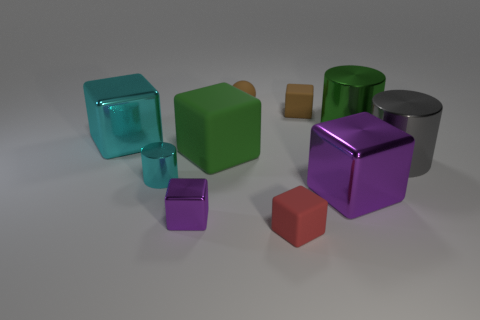There is a small rubber block that is behind the large green cylinder; is its color the same as the sphere that is to the left of the large green cylinder?
Your answer should be compact. Yes. Are there an equal number of tiny cyan metallic things that are left of the big rubber cube and large gray metallic things that are to the right of the red matte block?
Provide a short and direct response. Yes. Do the small purple cube and the tiny cyan thing have the same material?
Offer a very short reply. Yes. There is a purple metal object that is right of the tiny brown rubber block; is there a small matte block that is behind it?
Give a very brief answer. Yes. Are there any purple objects that have the same shape as the green rubber thing?
Your response must be concise. Yes. The big cylinder behind the cylinder right of the green cylinder is made of what material?
Your answer should be compact. Metal. The red block is what size?
Provide a succinct answer. Small. There is a green object that is the same material as the large purple cube; what size is it?
Your answer should be compact. Large. Do the purple metallic cube that is to the left of the red rubber block and the cyan cube have the same size?
Your response must be concise. No. The cyan metal thing behind the metal cylinder on the left side of the large green cylinder to the right of the red rubber block is what shape?
Keep it short and to the point. Cube. 